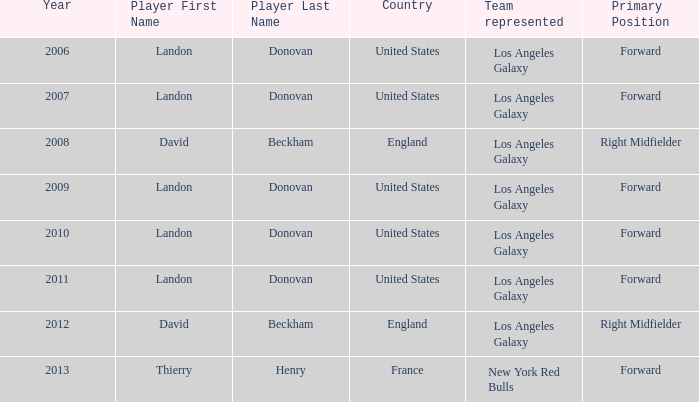What is the sum of all the years that Landon Donovan won the ESPY award? 5.0. 